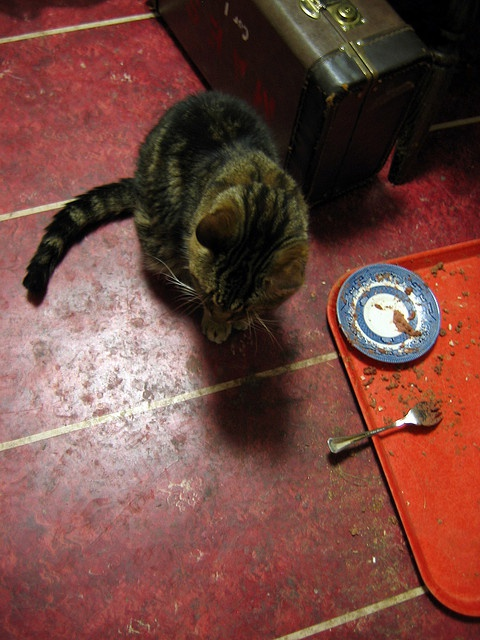Describe the objects in this image and their specific colors. I can see cat in black, darkgreen, and gray tones, suitcase in black, darkgreen, and gray tones, and fork in black, gray, brown, and maroon tones in this image. 